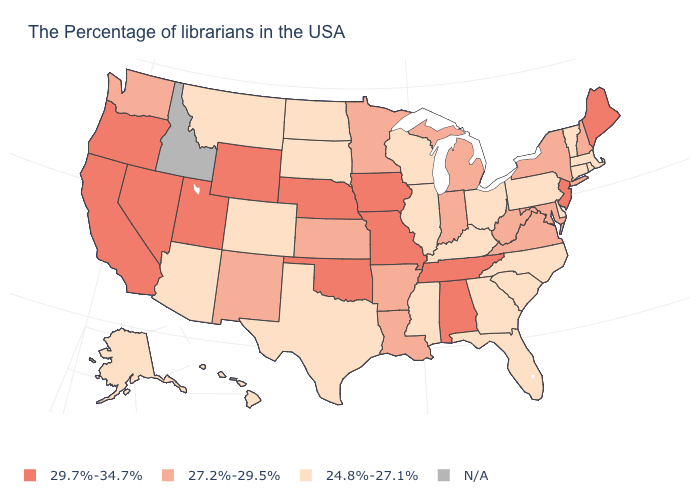Among the states that border New Jersey , does New York have the highest value?
Write a very short answer. Yes. How many symbols are there in the legend?
Concise answer only. 4. Name the states that have a value in the range 24.8%-27.1%?
Write a very short answer. Massachusetts, Rhode Island, Vermont, Connecticut, Delaware, Pennsylvania, North Carolina, South Carolina, Ohio, Florida, Georgia, Kentucky, Wisconsin, Illinois, Mississippi, Texas, South Dakota, North Dakota, Colorado, Montana, Arizona, Alaska, Hawaii. Name the states that have a value in the range 24.8%-27.1%?
Keep it brief. Massachusetts, Rhode Island, Vermont, Connecticut, Delaware, Pennsylvania, North Carolina, South Carolina, Ohio, Florida, Georgia, Kentucky, Wisconsin, Illinois, Mississippi, Texas, South Dakota, North Dakota, Colorado, Montana, Arizona, Alaska, Hawaii. Name the states that have a value in the range 27.2%-29.5%?
Answer briefly. New Hampshire, New York, Maryland, Virginia, West Virginia, Michigan, Indiana, Louisiana, Arkansas, Minnesota, Kansas, New Mexico, Washington. What is the value of South Carolina?
Keep it brief. 24.8%-27.1%. Among the states that border Illinois , which have the highest value?
Short answer required. Missouri, Iowa. Name the states that have a value in the range N/A?
Answer briefly. Idaho. What is the lowest value in states that border Pennsylvania?
Quick response, please. 24.8%-27.1%. What is the value of South Dakota?
Answer briefly. 24.8%-27.1%. Does Washington have the highest value in the USA?
Write a very short answer. No. Does Arizona have the highest value in the USA?
Write a very short answer. No. Name the states that have a value in the range 29.7%-34.7%?
Quick response, please. Maine, New Jersey, Alabama, Tennessee, Missouri, Iowa, Nebraska, Oklahoma, Wyoming, Utah, Nevada, California, Oregon. Name the states that have a value in the range 29.7%-34.7%?
Give a very brief answer. Maine, New Jersey, Alabama, Tennessee, Missouri, Iowa, Nebraska, Oklahoma, Wyoming, Utah, Nevada, California, Oregon. Name the states that have a value in the range N/A?
Short answer required. Idaho. 